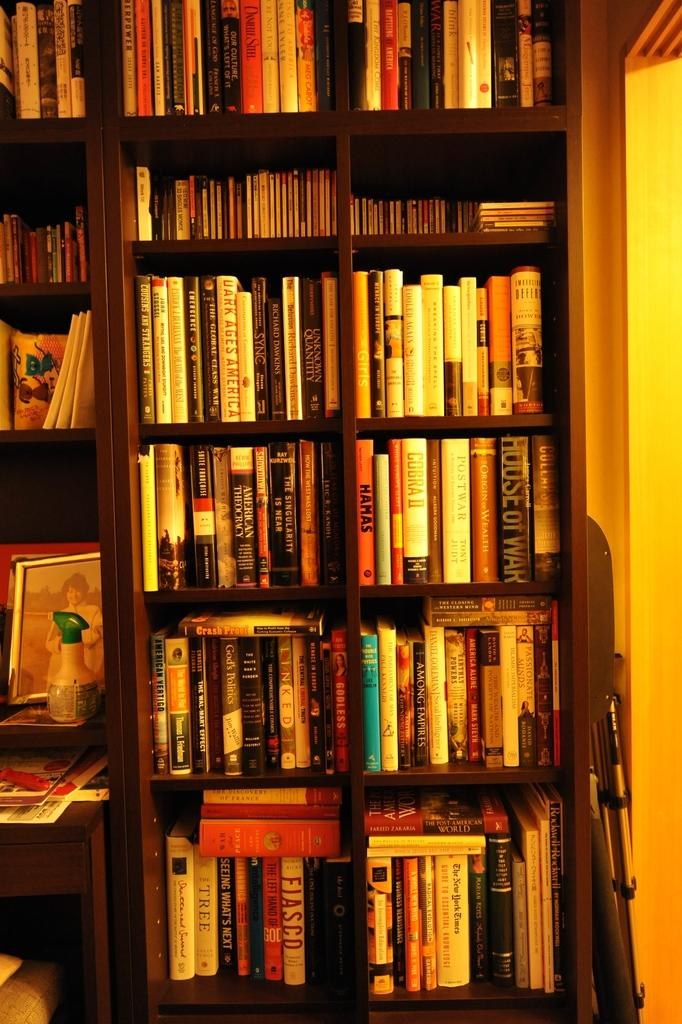What can be seen in large quantities in the image? There are lots of books in the image. What else is present on the shelves besides books? There is a photo frame and a bottle on the shelves. Can you describe the object on the right side of the shelves? Unfortunately, the provided facts do not give enough information to describe the object on the right side of the shelves. Can you see any jellyfish swimming in the image? No, there are no jellyfish present in the image. What type of appliance is visible on the shelves? There is no appliance visible in the image. 